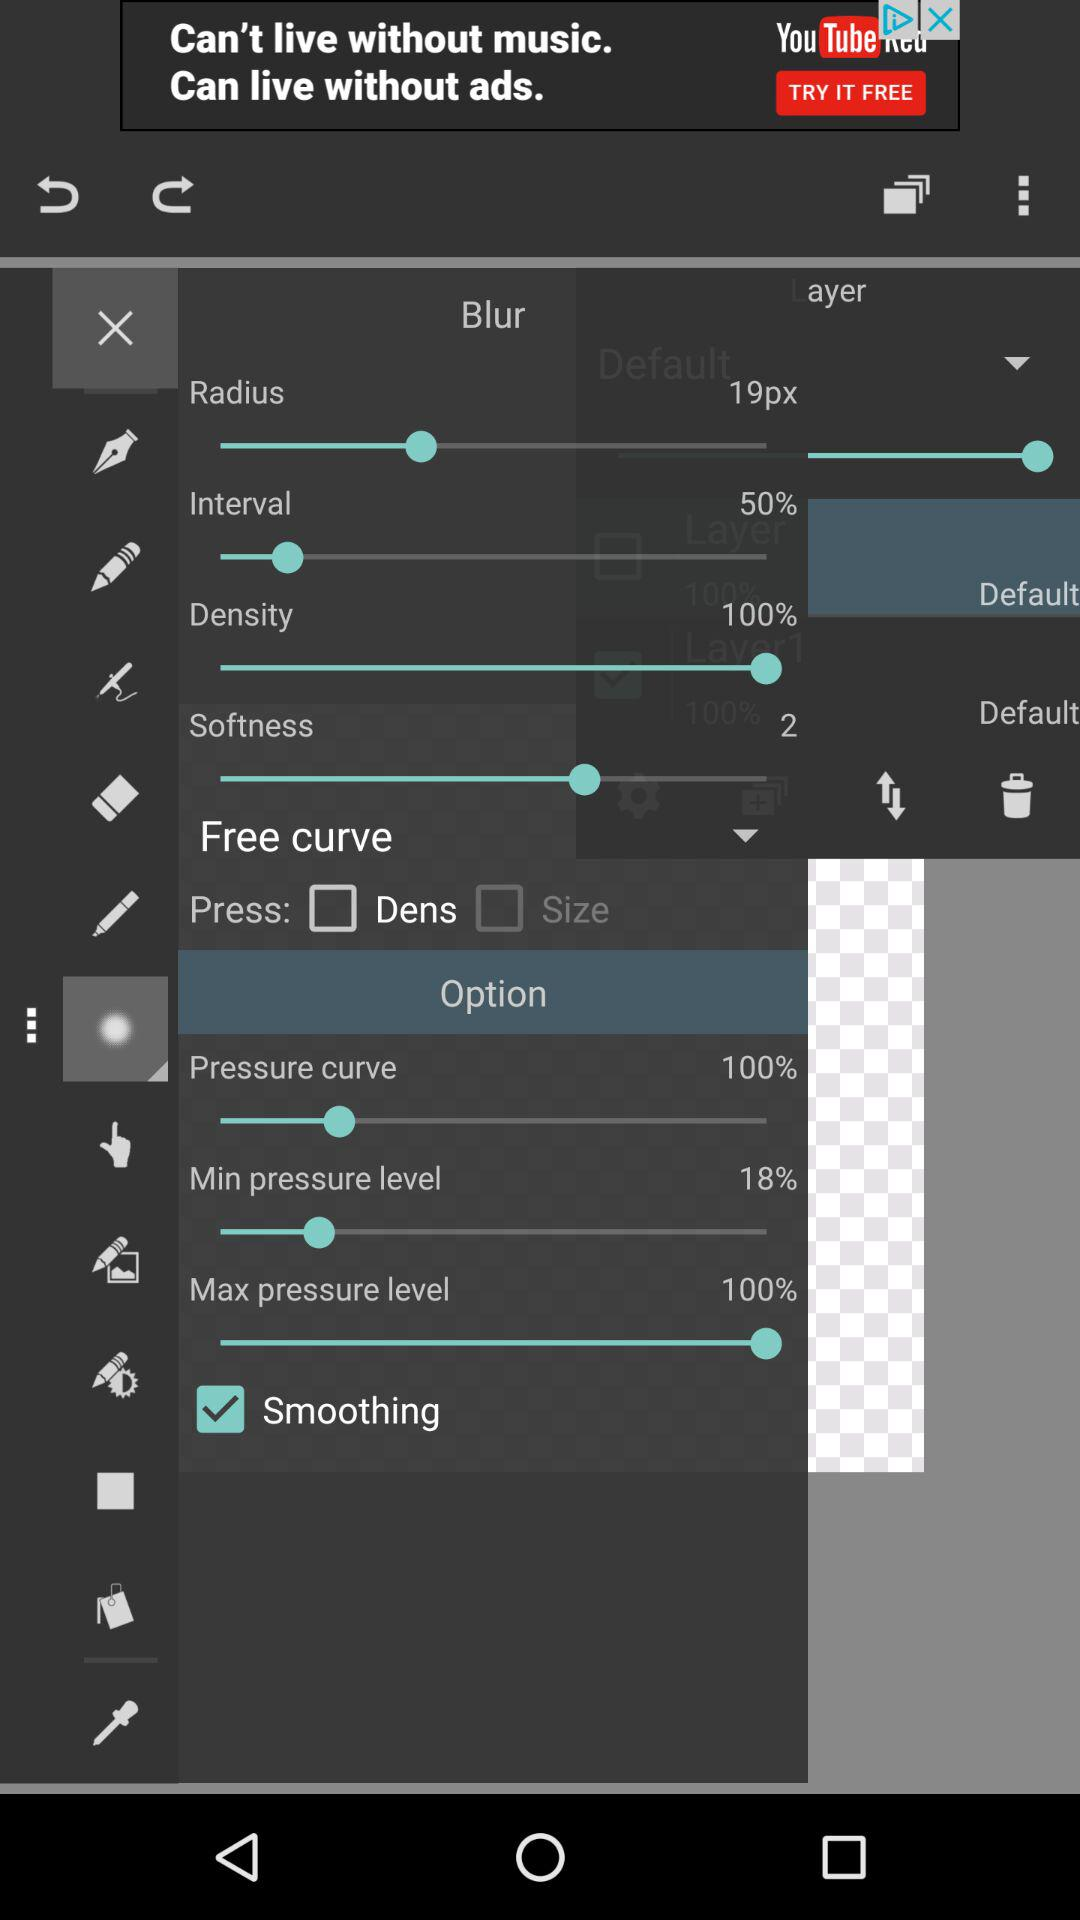What is the percentage of the maximum pressure level? The percentage of the maximum pressure level is 100. 